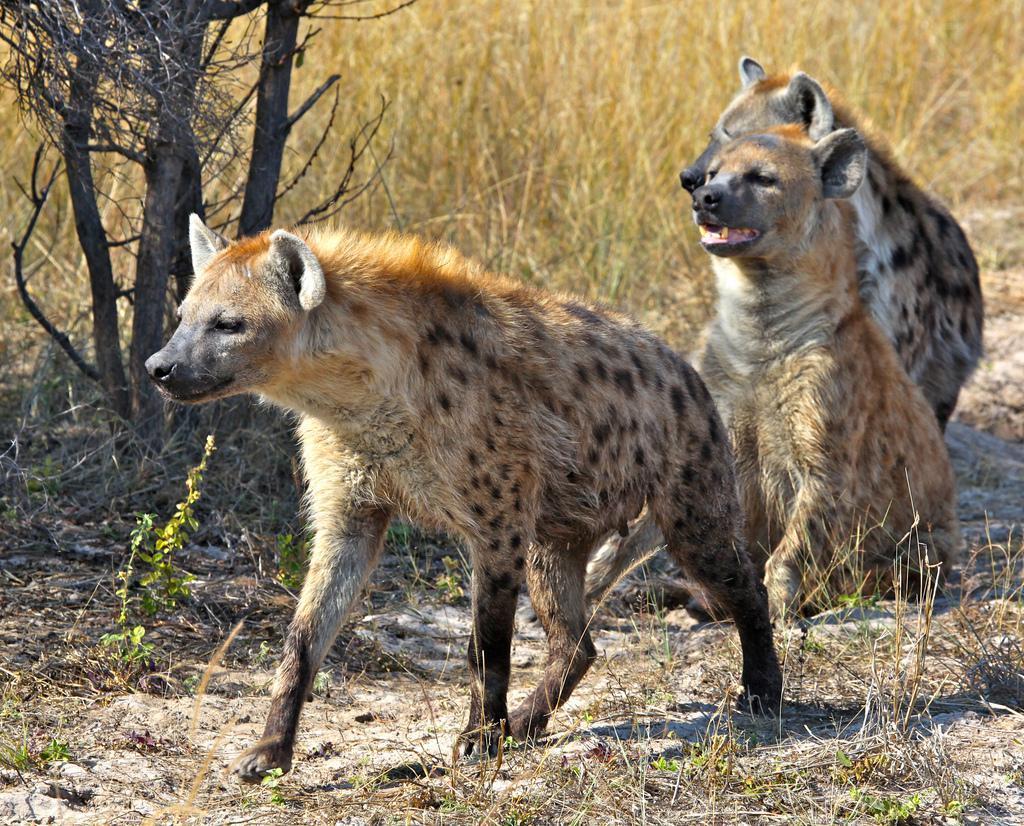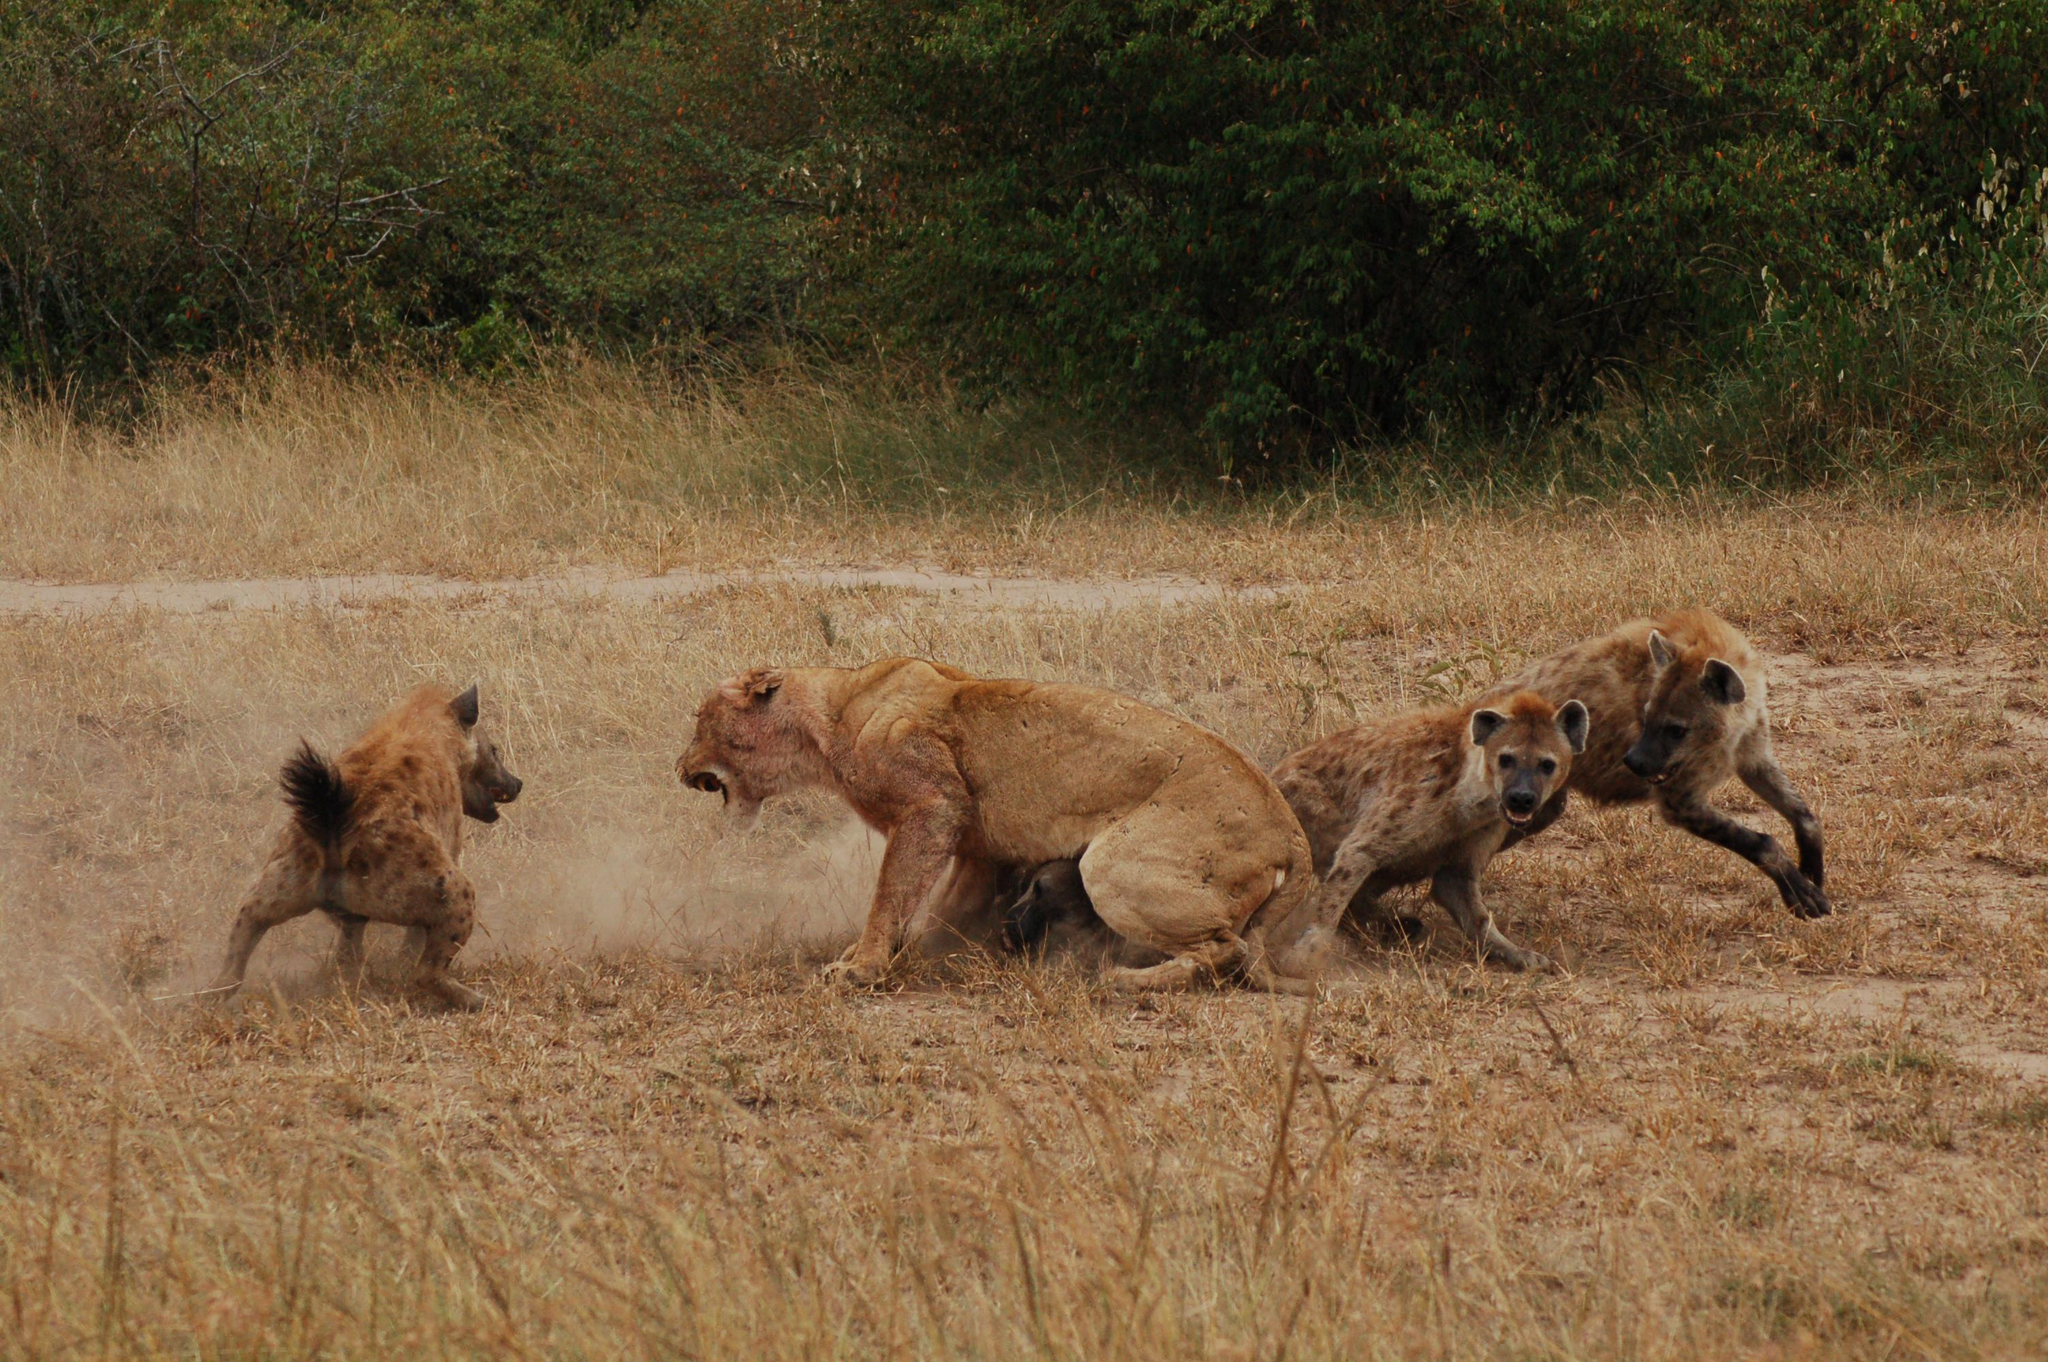The first image is the image on the left, the second image is the image on the right. For the images shown, is this caption "One image shows hyenas around an open-mouthed lion." true? Answer yes or no. Yes. The first image is the image on the left, the second image is the image on the right. For the images displayed, is the sentence "One of the images only contains hyenas" factually correct? Answer yes or no. Yes. 